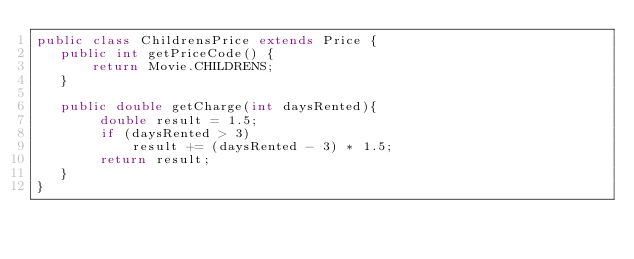<code> <loc_0><loc_0><loc_500><loc_500><_Java_>public class ChildrensPrice extends Price {
   public int getPriceCode() {
       return Movie.CHILDRENS;
   }

   public double getCharge(int daysRented){
        double result = 1.5;
        if (daysRented > 3)
            result += (daysRented - 3) * 1.5;
        return result;
   }
}</code> 